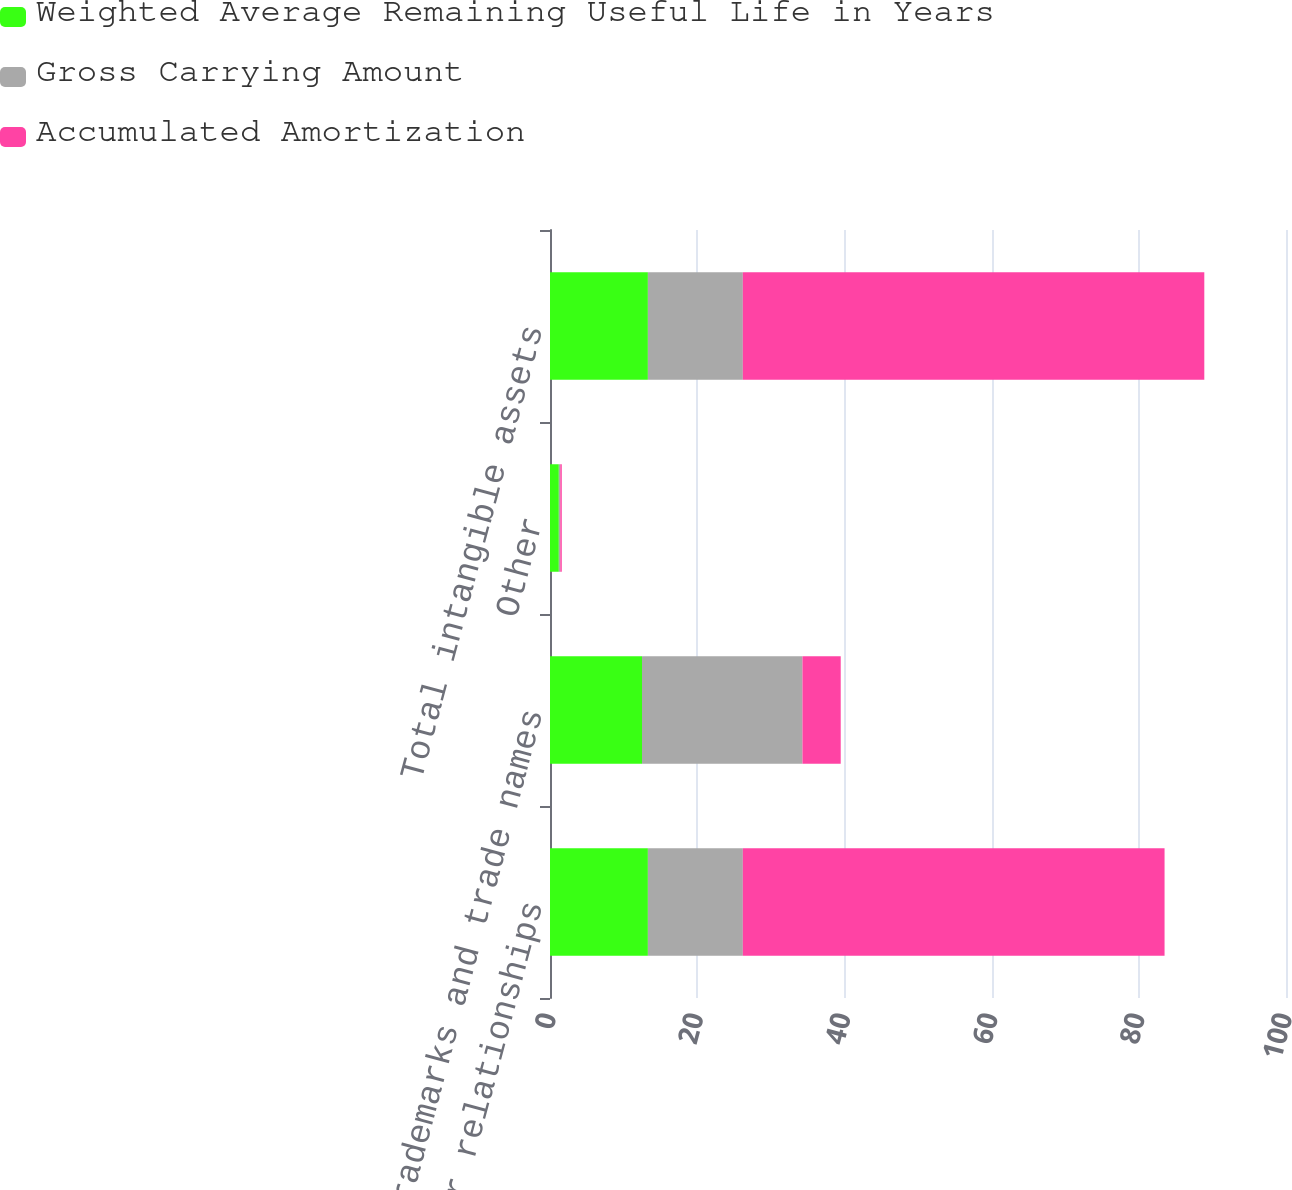Convert chart. <chart><loc_0><loc_0><loc_500><loc_500><stacked_bar_chart><ecel><fcel>Customer relationships<fcel>Trademarks and trade names<fcel>Other<fcel>Total intangible assets<nl><fcel>Weighted Average Remaining Useful Life in Years<fcel>13.3<fcel>12.5<fcel>1.2<fcel>13.3<nl><fcel>Gross Carrying Amount<fcel>12.9<fcel>21.8<fcel>0.2<fcel>12.9<nl><fcel>Accumulated Amortization<fcel>57.3<fcel>5.2<fcel>0.2<fcel>62.7<nl></chart> 